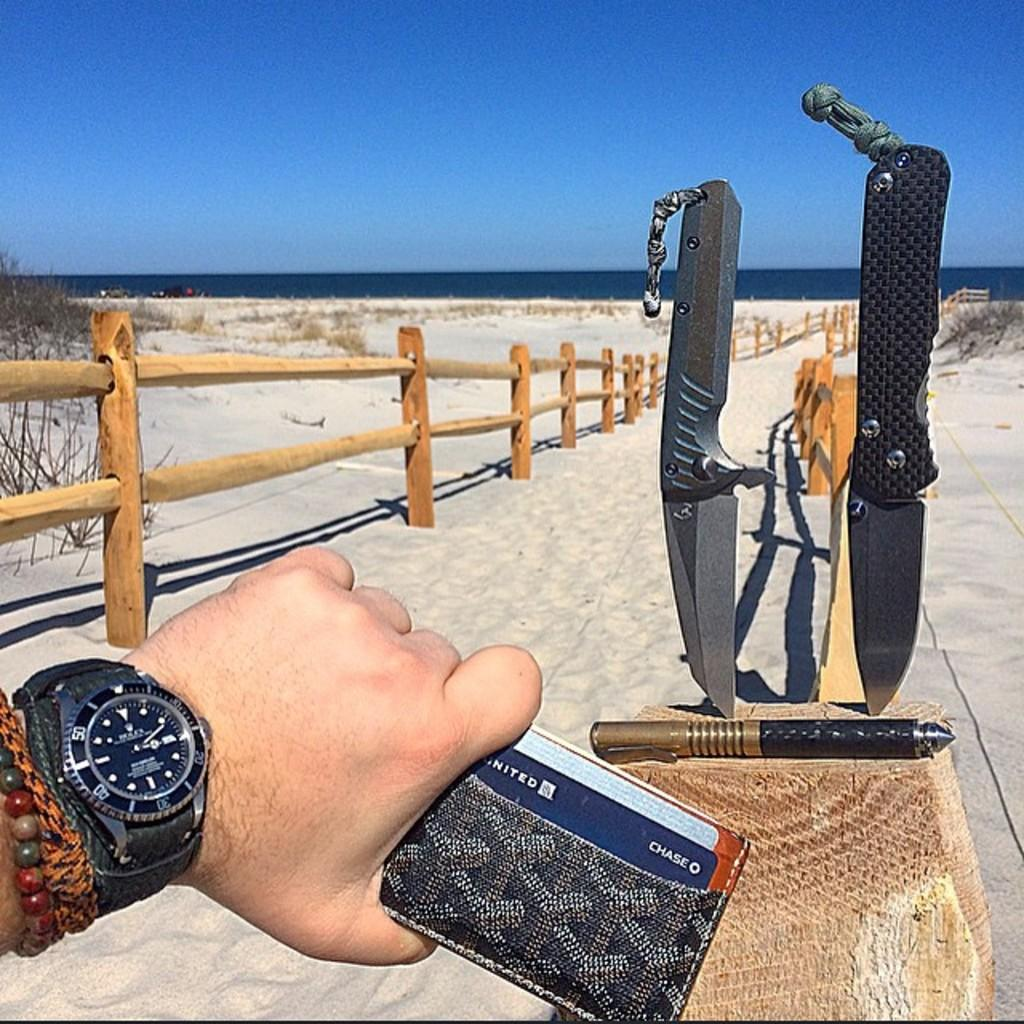Provide a one-sentence caption for the provided image. Two knives are displayed at a sandy beach, with a person holding a wallet with a United Chase card in the foreground. 